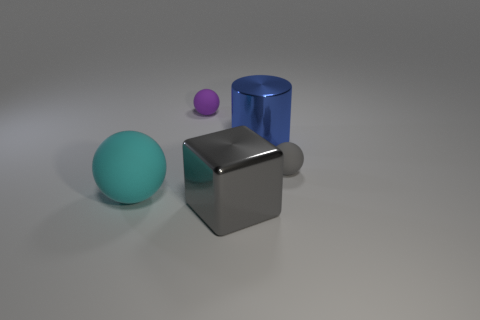The large object that is both right of the large sphere and left of the large blue metallic object has what shape?
Offer a terse response. Cube. Are there any big cyan things that have the same material as the tiny gray thing?
Provide a short and direct response. Yes. There is a ball that is the same color as the shiny cube; what is it made of?
Keep it short and to the point. Rubber. Do the big thing behind the big cyan matte sphere and the small object that is to the left of the gray rubber thing have the same material?
Your answer should be compact. No. Is the number of blue objects greater than the number of blue metallic cubes?
Keep it short and to the point. Yes. What color is the small matte ball that is right of the tiny matte sphere behind the small sphere to the right of the cube?
Provide a succinct answer. Gray. Do the large metallic object in front of the small gray object and the matte thing on the right side of the block have the same color?
Provide a short and direct response. Yes. There is a tiny matte sphere that is right of the large gray shiny block; what number of shiny objects are in front of it?
Make the answer very short. 1. Is there a blue shiny sphere?
Offer a terse response. No. What number of other objects are the same color as the big metal block?
Your answer should be very brief. 1. 